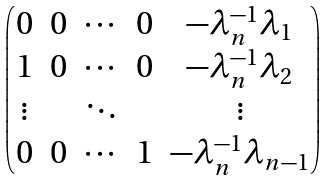Convert formula to latex. <formula><loc_0><loc_0><loc_500><loc_500>\begin{pmatrix} 0 & 0 & \cdots & 0 & - \lambda _ { n } ^ { - 1 } \lambda _ { 1 } \\ 1 & 0 & \cdots & 0 & - \lambda _ { n } ^ { - 1 } \lambda _ { 2 } \\ \vdots & & \ddots & & \vdots \\ 0 & 0 & \cdots & 1 & - \lambda _ { n } ^ { - 1 } \lambda _ { n - 1 } \end{pmatrix}</formula> 